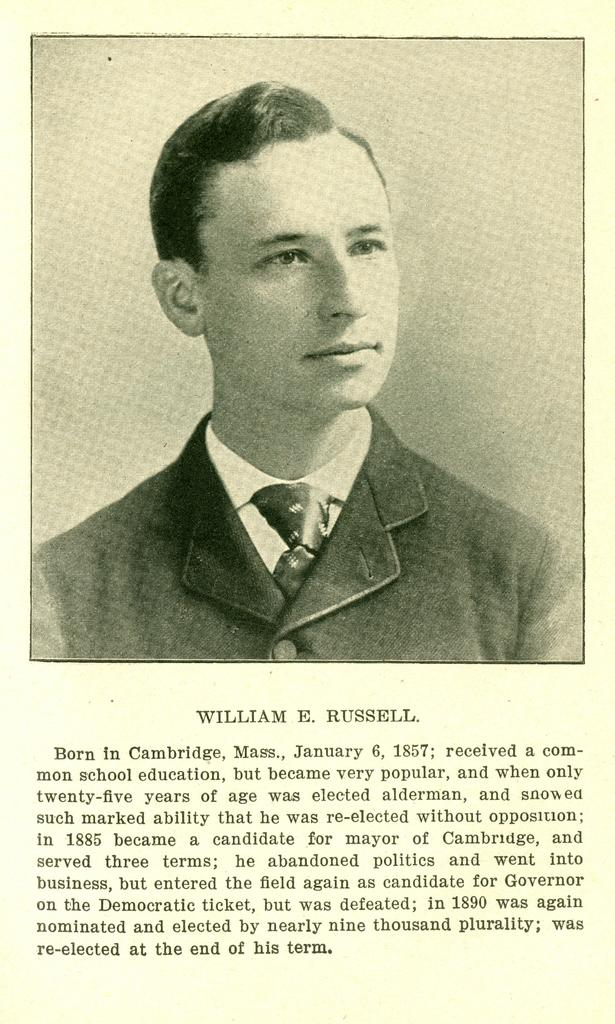What is the main subject of the image? There is a picture of a person in the image. What additional information is provided with the picture? There is text written under the picture. How many times does the person in the image fold their arms? There is no indication in the image that the person is folding their arms, so it cannot be determined from the picture. 